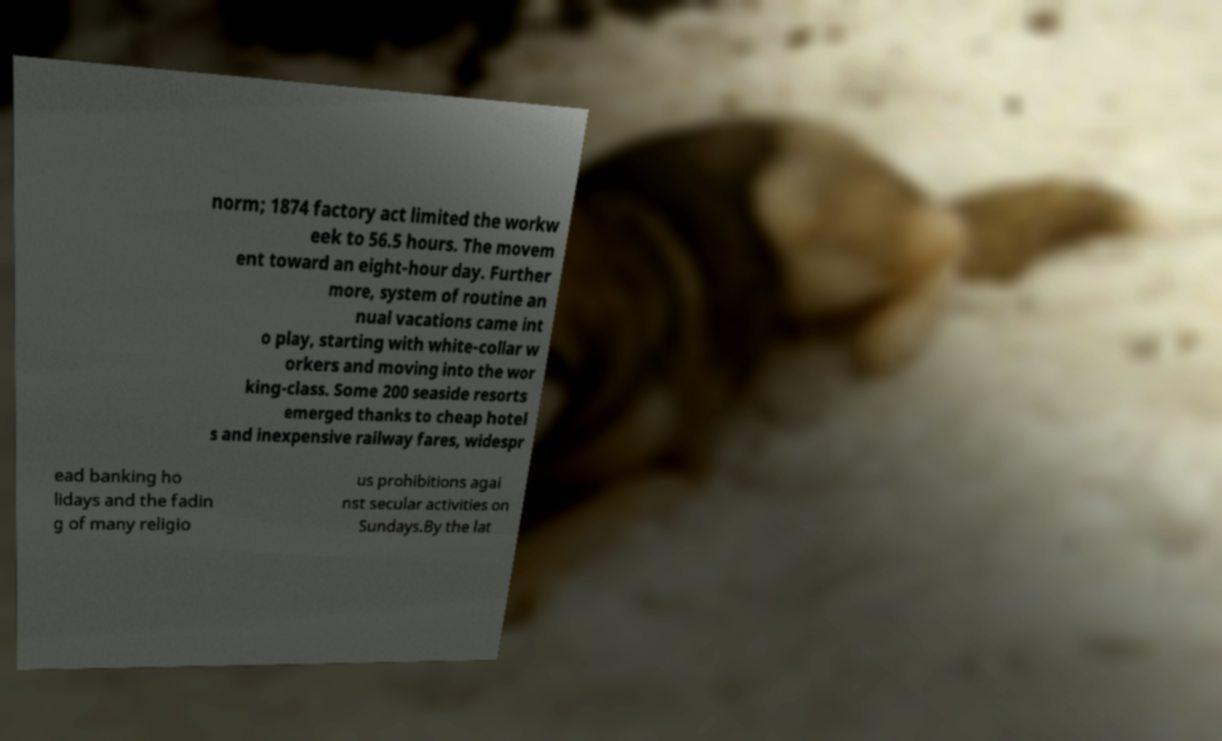Can you read and provide the text displayed in the image?This photo seems to have some interesting text. Can you extract and type it out for me? norm; 1874 factory act limited the workw eek to 56.5 hours. The movem ent toward an eight-hour day. Further more, system of routine an nual vacations came int o play, starting with white-collar w orkers and moving into the wor king-class. Some 200 seaside resorts emerged thanks to cheap hotel s and inexpensive railway fares, widespr ead banking ho lidays and the fadin g of many religio us prohibitions agai nst secular activities on Sundays.By the lat 